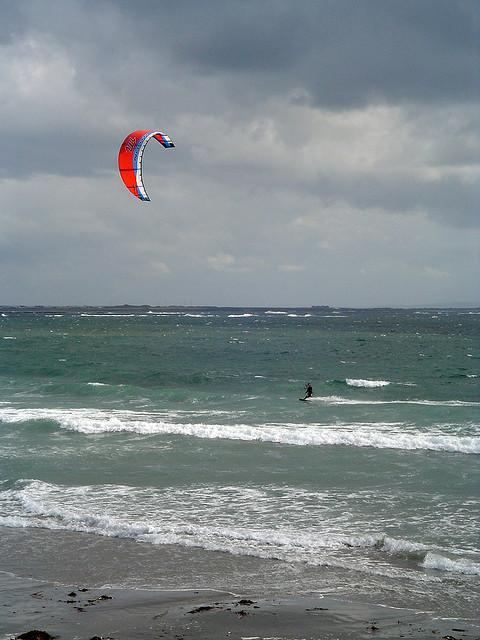What is the boarder about to hit? Please explain your reasoning. beach. The man is coming in towards the sand at end of water. 